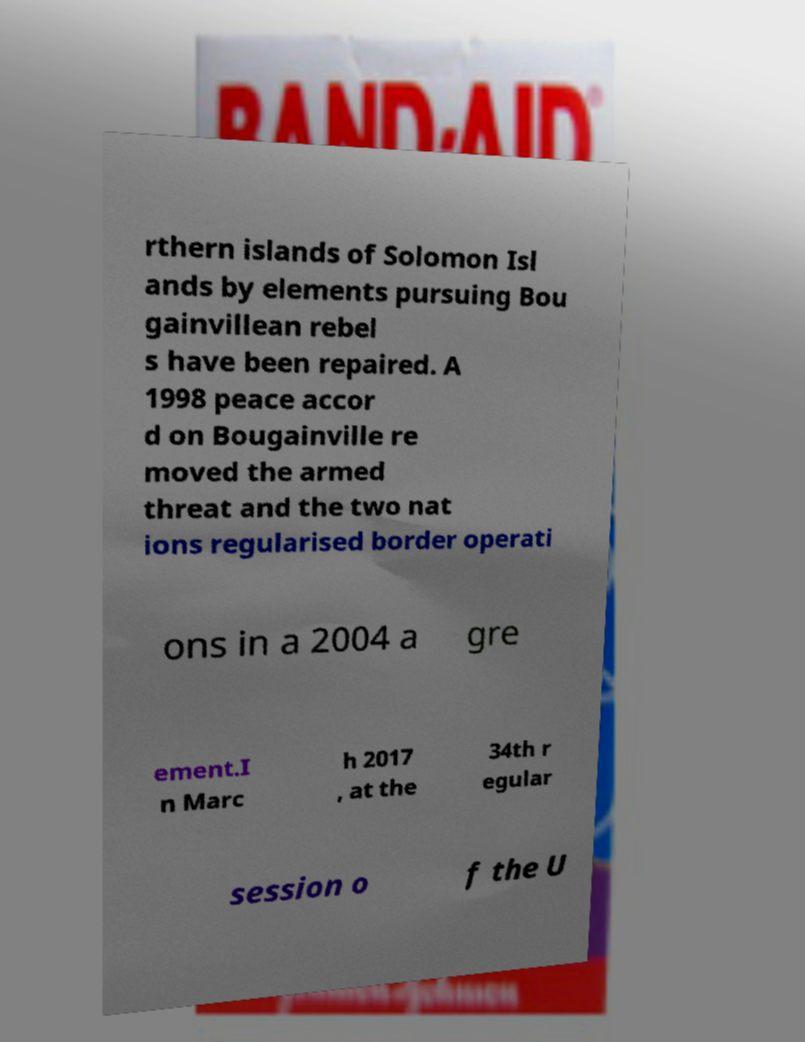Can you read and provide the text displayed in the image?This photo seems to have some interesting text. Can you extract and type it out for me? rthern islands of Solomon Isl ands by elements pursuing Bou gainvillean rebel s have been repaired. A 1998 peace accor d on Bougainville re moved the armed threat and the two nat ions regularised border operati ons in a 2004 a gre ement.I n Marc h 2017 , at the 34th r egular session o f the U 